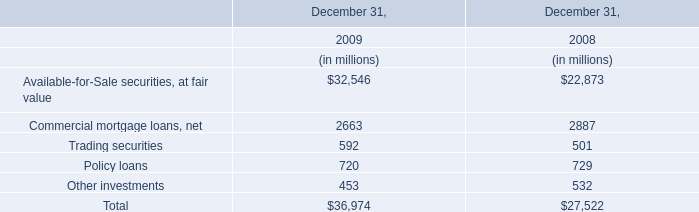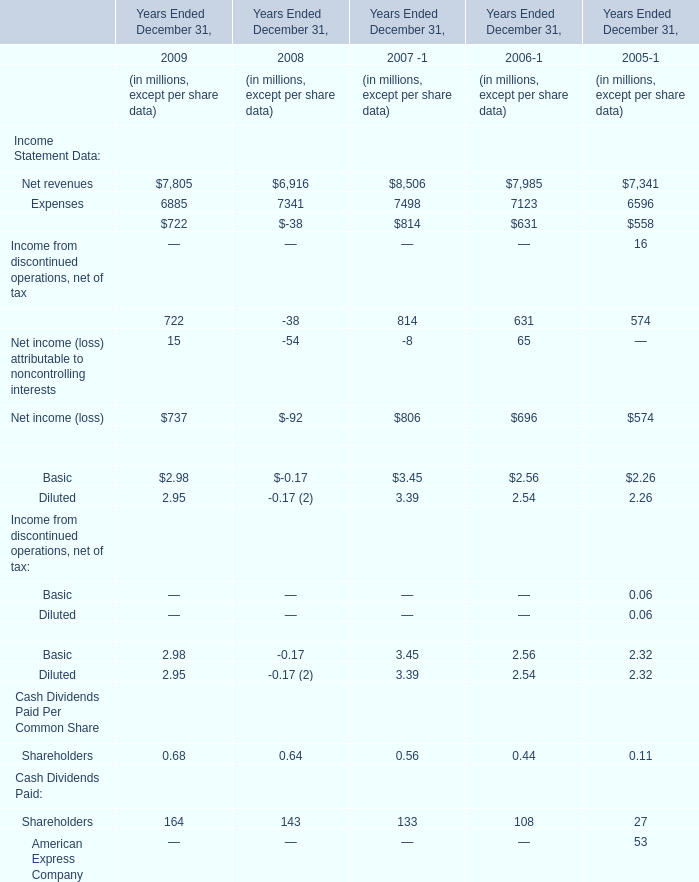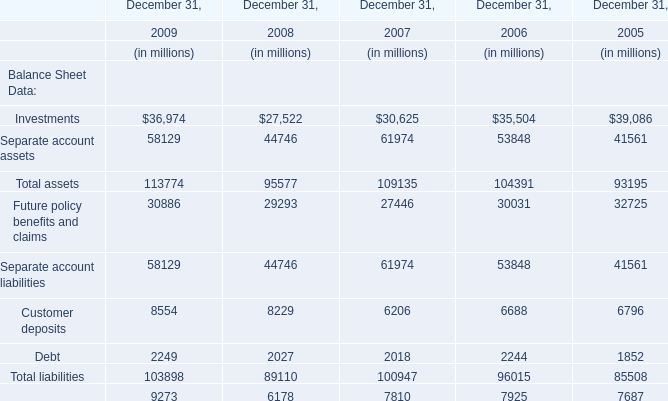What's the average of Net revenues the in the years where Expenses is positive? (in million) 
Computations: (((((7805 + 6916) + 8506) + 7985) + 7341) / 5)
Answer: 7710.6. 